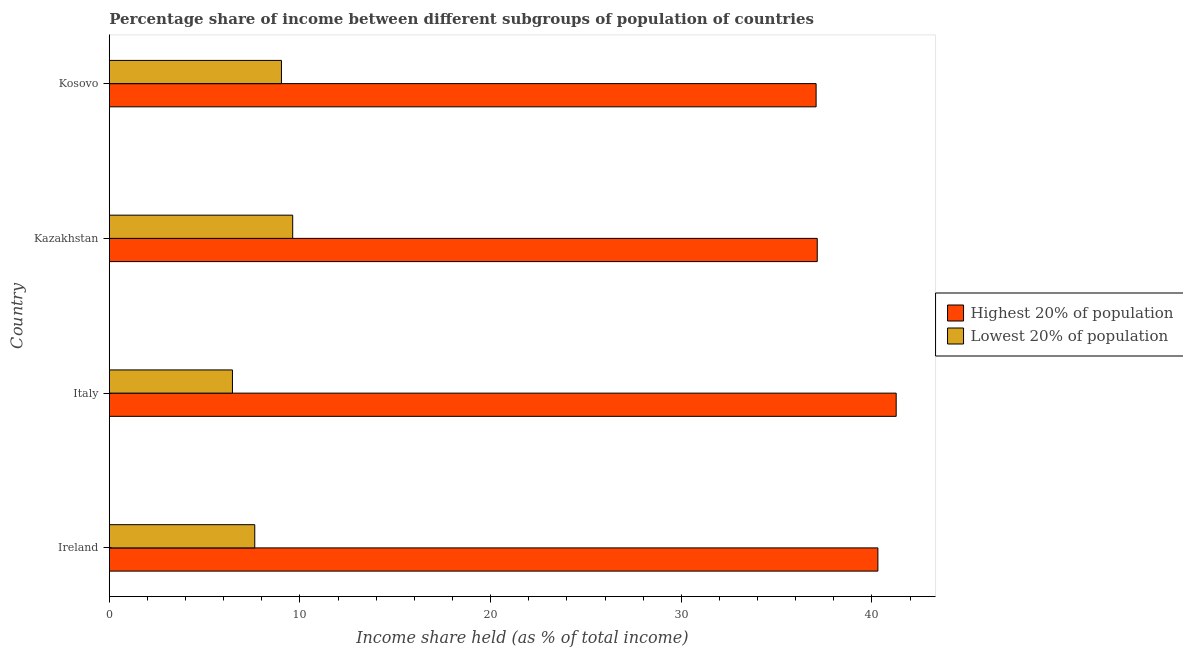How many groups of bars are there?
Give a very brief answer. 4. Are the number of bars per tick equal to the number of legend labels?
Make the answer very short. Yes. How many bars are there on the 1st tick from the bottom?
Provide a short and direct response. 2. What is the label of the 1st group of bars from the top?
Provide a short and direct response. Kosovo. In how many cases, is the number of bars for a given country not equal to the number of legend labels?
Give a very brief answer. 0. What is the income share held by lowest 20% of the population in Italy?
Provide a short and direct response. 6.46. Across all countries, what is the maximum income share held by lowest 20% of the population?
Provide a succinct answer. 9.62. Across all countries, what is the minimum income share held by lowest 20% of the population?
Give a very brief answer. 6.46. In which country was the income share held by lowest 20% of the population maximum?
Provide a short and direct response. Kazakhstan. In which country was the income share held by highest 20% of the population minimum?
Provide a succinct answer. Kosovo. What is the total income share held by highest 20% of the population in the graph?
Offer a terse response. 155.78. What is the difference between the income share held by highest 20% of the population in Ireland and that in Italy?
Keep it short and to the point. -0.96. What is the difference between the income share held by highest 20% of the population in Kosovo and the income share held by lowest 20% of the population in Italy?
Make the answer very short. 30.61. What is the average income share held by lowest 20% of the population per country?
Provide a short and direct response. 8.19. What is the difference between the income share held by lowest 20% of the population and income share held by highest 20% of the population in Ireland?
Your answer should be compact. -32.68. In how many countries, is the income share held by highest 20% of the population greater than 32 %?
Provide a succinct answer. 4. What is the ratio of the income share held by lowest 20% of the population in Ireland to that in Kazakhstan?
Offer a terse response. 0.79. Is the difference between the income share held by highest 20% of the population in Ireland and Italy greater than the difference between the income share held by lowest 20% of the population in Ireland and Italy?
Keep it short and to the point. No. What is the difference between the highest and the second highest income share held by lowest 20% of the population?
Offer a terse response. 0.59. What is the difference between the highest and the lowest income share held by highest 20% of the population?
Provide a succinct answer. 4.2. In how many countries, is the income share held by highest 20% of the population greater than the average income share held by highest 20% of the population taken over all countries?
Offer a terse response. 2. What does the 1st bar from the top in Ireland represents?
Offer a very short reply. Lowest 20% of population. What does the 1st bar from the bottom in Italy represents?
Ensure brevity in your answer.  Highest 20% of population. How many bars are there?
Your answer should be compact. 8. Are all the bars in the graph horizontal?
Provide a succinct answer. Yes. How many countries are there in the graph?
Your response must be concise. 4. What is the difference between two consecutive major ticks on the X-axis?
Make the answer very short. 10. Does the graph contain grids?
Provide a succinct answer. No. How many legend labels are there?
Your answer should be compact. 2. How are the legend labels stacked?
Keep it short and to the point. Vertical. What is the title of the graph?
Make the answer very short. Percentage share of income between different subgroups of population of countries. Does "Merchandise imports" appear as one of the legend labels in the graph?
Provide a short and direct response. No. What is the label or title of the X-axis?
Give a very brief answer. Income share held (as % of total income). What is the Income share held (as % of total income) in Highest 20% of population in Ireland?
Your answer should be very brief. 40.31. What is the Income share held (as % of total income) in Lowest 20% of population in Ireland?
Your answer should be very brief. 7.63. What is the Income share held (as % of total income) of Highest 20% of population in Italy?
Ensure brevity in your answer.  41.27. What is the Income share held (as % of total income) of Lowest 20% of population in Italy?
Your answer should be compact. 6.46. What is the Income share held (as % of total income) in Highest 20% of population in Kazakhstan?
Keep it short and to the point. 37.13. What is the Income share held (as % of total income) in Lowest 20% of population in Kazakhstan?
Offer a terse response. 9.62. What is the Income share held (as % of total income) in Highest 20% of population in Kosovo?
Provide a short and direct response. 37.07. What is the Income share held (as % of total income) in Lowest 20% of population in Kosovo?
Offer a very short reply. 9.03. Across all countries, what is the maximum Income share held (as % of total income) of Highest 20% of population?
Your response must be concise. 41.27. Across all countries, what is the maximum Income share held (as % of total income) in Lowest 20% of population?
Offer a terse response. 9.62. Across all countries, what is the minimum Income share held (as % of total income) in Highest 20% of population?
Provide a succinct answer. 37.07. Across all countries, what is the minimum Income share held (as % of total income) in Lowest 20% of population?
Ensure brevity in your answer.  6.46. What is the total Income share held (as % of total income) in Highest 20% of population in the graph?
Offer a very short reply. 155.78. What is the total Income share held (as % of total income) in Lowest 20% of population in the graph?
Your answer should be compact. 32.74. What is the difference between the Income share held (as % of total income) of Highest 20% of population in Ireland and that in Italy?
Provide a succinct answer. -0.96. What is the difference between the Income share held (as % of total income) in Lowest 20% of population in Ireland and that in Italy?
Provide a short and direct response. 1.17. What is the difference between the Income share held (as % of total income) in Highest 20% of population in Ireland and that in Kazakhstan?
Provide a succinct answer. 3.18. What is the difference between the Income share held (as % of total income) of Lowest 20% of population in Ireland and that in Kazakhstan?
Provide a succinct answer. -1.99. What is the difference between the Income share held (as % of total income) in Highest 20% of population in Ireland and that in Kosovo?
Your answer should be compact. 3.24. What is the difference between the Income share held (as % of total income) of Lowest 20% of population in Ireland and that in Kosovo?
Make the answer very short. -1.4. What is the difference between the Income share held (as % of total income) in Highest 20% of population in Italy and that in Kazakhstan?
Keep it short and to the point. 4.14. What is the difference between the Income share held (as % of total income) of Lowest 20% of population in Italy and that in Kazakhstan?
Provide a succinct answer. -3.16. What is the difference between the Income share held (as % of total income) in Highest 20% of population in Italy and that in Kosovo?
Your answer should be very brief. 4.2. What is the difference between the Income share held (as % of total income) of Lowest 20% of population in Italy and that in Kosovo?
Offer a very short reply. -2.57. What is the difference between the Income share held (as % of total income) in Lowest 20% of population in Kazakhstan and that in Kosovo?
Your response must be concise. 0.59. What is the difference between the Income share held (as % of total income) in Highest 20% of population in Ireland and the Income share held (as % of total income) in Lowest 20% of population in Italy?
Provide a short and direct response. 33.85. What is the difference between the Income share held (as % of total income) of Highest 20% of population in Ireland and the Income share held (as % of total income) of Lowest 20% of population in Kazakhstan?
Make the answer very short. 30.69. What is the difference between the Income share held (as % of total income) in Highest 20% of population in Ireland and the Income share held (as % of total income) in Lowest 20% of population in Kosovo?
Your answer should be compact. 31.28. What is the difference between the Income share held (as % of total income) of Highest 20% of population in Italy and the Income share held (as % of total income) of Lowest 20% of population in Kazakhstan?
Offer a terse response. 31.65. What is the difference between the Income share held (as % of total income) of Highest 20% of population in Italy and the Income share held (as % of total income) of Lowest 20% of population in Kosovo?
Keep it short and to the point. 32.24. What is the difference between the Income share held (as % of total income) in Highest 20% of population in Kazakhstan and the Income share held (as % of total income) in Lowest 20% of population in Kosovo?
Your answer should be compact. 28.1. What is the average Income share held (as % of total income) of Highest 20% of population per country?
Ensure brevity in your answer.  38.95. What is the average Income share held (as % of total income) in Lowest 20% of population per country?
Make the answer very short. 8.19. What is the difference between the Income share held (as % of total income) of Highest 20% of population and Income share held (as % of total income) of Lowest 20% of population in Ireland?
Your answer should be very brief. 32.68. What is the difference between the Income share held (as % of total income) in Highest 20% of population and Income share held (as % of total income) in Lowest 20% of population in Italy?
Offer a terse response. 34.81. What is the difference between the Income share held (as % of total income) in Highest 20% of population and Income share held (as % of total income) in Lowest 20% of population in Kazakhstan?
Ensure brevity in your answer.  27.51. What is the difference between the Income share held (as % of total income) of Highest 20% of population and Income share held (as % of total income) of Lowest 20% of population in Kosovo?
Provide a succinct answer. 28.04. What is the ratio of the Income share held (as % of total income) in Highest 20% of population in Ireland to that in Italy?
Offer a terse response. 0.98. What is the ratio of the Income share held (as % of total income) in Lowest 20% of population in Ireland to that in Italy?
Give a very brief answer. 1.18. What is the ratio of the Income share held (as % of total income) in Highest 20% of population in Ireland to that in Kazakhstan?
Provide a short and direct response. 1.09. What is the ratio of the Income share held (as % of total income) of Lowest 20% of population in Ireland to that in Kazakhstan?
Your answer should be very brief. 0.79. What is the ratio of the Income share held (as % of total income) of Highest 20% of population in Ireland to that in Kosovo?
Make the answer very short. 1.09. What is the ratio of the Income share held (as % of total income) in Lowest 20% of population in Ireland to that in Kosovo?
Offer a terse response. 0.84. What is the ratio of the Income share held (as % of total income) of Highest 20% of population in Italy to that in Kazakhstan?
Your answer should be compact. 1.11. What is the ratio of the Income share held (as % of total income) in Lowest 20% of population in Italy to that in Kazakhstan?
Ensure brevity in your answer.  0.67. What is the ratio of the Income share held (as % of total income) in Highest 20% of population in Italy to that in Kosovo?
Offer a terse response. 1.11. What is the ratio of the Income share held (as % of total income) in Lowest 20% of population in Italy to that in Kosovo?
Provide a succinct answer. 0.72. What is the ratio of the Income share held (as % of total income) in Lowest 20% of population in Kazakhstan to that in Kosovo?
Keep it short and to the point. 1.07. What is the difference between the highest and the second highest Income share held (as % of total income) in Highest 20% of population?
Keep it short and to the point. 0.96. What is the difference between the highest and the second highest Income share held (as % of total income) of Lowest 20% of population?
Your response must be concise. 0.59. What is the difference between the highest and the lowest Income share held (as % of total income) of Lowest 20% of population?
Make the answer very short. 3.16. 